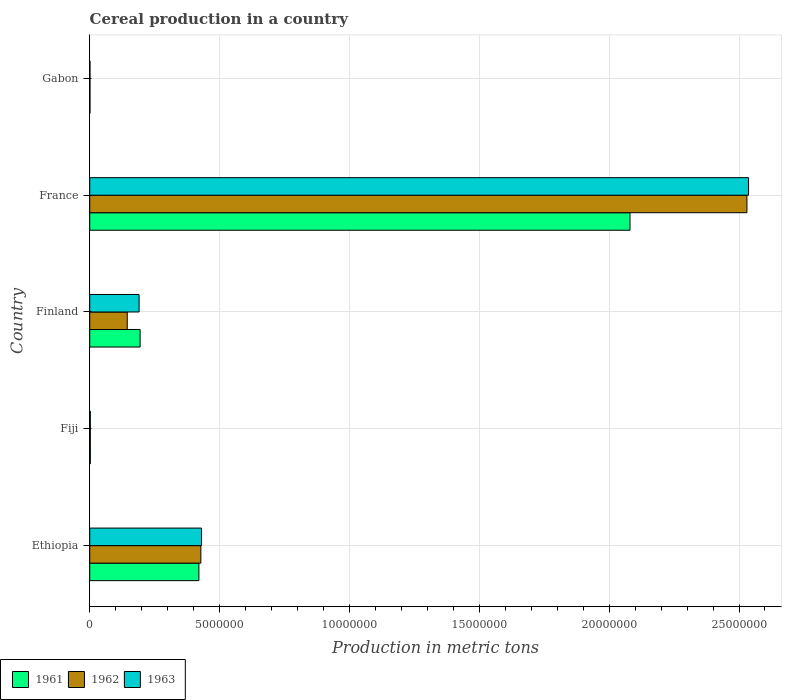How many different coloured bars are there?
Offer a terse response. 3. How many bars are there on the 1st tick from the top?
Ensure brevity in your answer.  3. How many bars are there on the 5th tick from the bottom?
Provide a succinct answer. 3. What is the label of the 4th group of bars from the top?
Offer a very short reply. Fiji. In how many cases, is the number of bars for a given country not equal to the number of legend labels?
Make the answer very short. 0. What is the total cereal production in 1963 in France?
Your answer should be very brief. 2.54e+07. Across all countries, what is the maximum total cereal production in 1963?
Your answer should be very brief. 2.54e+07. Across all countries, what is the minimum total cereal production in 1962?
Provide a short and direct response. 9053. In which country was the total cereal production in 1962 maximum?
Provide a short and direct response. France. In which country was the total cereal production in 1962 minimum?
Provide a succinct answer. Gabon. What is the total total cereal production in 1962 in the graph?
Provide a short and direct response. 3.11e+07. What is the difference between the total cereal production in 1963 in Fiji and that in Gabon?
Offer a very short reply. 1.30e+04. What is the difference between the total cereal production in 1962 in Fiji and the total cereal production in 1961 in Finland?
Your answer should be very brief. -1.92e+06. What is the average total cereal production in 1962 per country?
Offer a very short reply. 6.21e+06. What is the difference between the total cereal production in 1961 and total cereal production in 1963 in Gabon?
Provide a succinct answer. 112. In how many countries, is the total cereal production in 1963 greater than 13000000 metric tons?
Offer a terse response. 1. What is the ratio of the total cereal production in 1963 in Finland to that in Gabon?
Your answer should be very brief. 207.21. Is the total cereal production in 1962 in Ethiopia less than that in France?
Offer a terse response. Yes. Is the difference between the total cereal production in 1961 in Ethiopia and France greater than the difference between the total cereal production in 1963 in Ethiopia and France?
Your answer should be compact. Yes. What is the difference between the highest and the second highest total cereal production in 1961?
Keep it short and to the point. 1.66e+07. What is the difference between the highest and the lowest total cereal production in 1961?
Give a very brief answer. 2.08e+07. In how many countries, is the total cereal production in 1961 greater than the average total cereal production in 1961 taken over all countries?
Provide a succinct answer. 1. What is the difference between two consecutive major ticks on the X-axis?
Your answer should be very brief. 5.00e+06. Does the graph contain any zero values?
Offer a terse response. No. Where does the legend appear in the graph?
Offer a terse response. Bottom left. How many legend labels are there?
Provide a short and direct response. 3. What is the title of the graph?
Make the answer very short. Cereal production in a country. Does "1979" appear as one of the legend labels in the graph?
Your answer should be compact. No. What is the label or title of the X-axis?
Provide a succinct answer. Production in metric tons. What is the Production in metric tons in 1961 in Ethiopia?
Your answer should be very brief. 4.20e+06. What is the Production in metric tons of 1962 in Ethiopia?
Provide a short and direct response. 4.28e+06. What is the Production in metric tons in 1963 in Ethiopia?
Your answer should be compact. 4.30e+06. What is the Production in metric tons of 1961 in Fiji?
Provide a succinct answer. 2.30e+04. What is the Production in metric tons in 1962 in Fiji?
Give a very brief answer. 2.27e+04. What is the Production in metric tons in 1963 in Fiji?
Your response must be concise. 2.22e+04. What is the Production in metric tons in 1961 in Finland?
Your response must be concise. 1.94e+06. What is the Production in metric tons in 1962 in Finland?
Give a very brief answer. 1.44e+06. What is the Production in metric tons in 1963 in Finland?
Ensure brevity in your answer.  1.90e+06. What is the Production in metric tons of 1961 in France?
Ensure brevity in your answer.  2.08e+07. What is the Production in metric tons in 1962 in France?
Provide a succinct answer. 2.53e+07. What is the Production in metric tons of 1963 in France?
Your answer should be very brief. 2.54e+07. What is the Production in metric tons of 1961 in Gabon?
Offer a terse response. 9285. What is the Production in metric tons in 1962 in Gabon?
Ensure brevity in your answer.  9053. What is the Production in metric tons in 1963 in Gabon?
Provide a succinct answer. 9173. Across all countries, what is the maximum Production in metric tons in 1961?
Your answer should be very brief. 2.08e+07. Across all countries, what is the maximum Production in metric tons in 1962?
Ensure brevity in your answer.  2.53e+07. Across all countries, what is the maximum Production in metric tons of 1963?
Make the answer very short. 2.54e+07. Across all countries, what is the minimum Production in metric tons in 1961?
Offer a very short reply. 9285. Across all countries, what is the minimum Production in metric tons in 1962?
Your response must be concise. 9053. Across all countries, what is the minimum Production in metric tons of 1963?
Give a very brief answer. 9173. What is the total Production in metric tons of 1961 in the graph?
Offer a very short reply. 2.70e+07. What is the total Production in metric tons of 1962 in the graph?
Provide a short and direct response. 3.11e+07. What is the total Production in metric tons in 1963 in the graph?
Give a very brief answer. 3.16e+07. What is the difference between the Production in metric tons in 1961 in Ethiopia and that in Fiji?
Offer a terse response. 4.18e+06. What is the difference between the Production in metric tons of 1962 in Ethiopia and that in Fiji?
Provide a succinct answer. 4.26e+06. What is the difference between the Production in metric tons in 1963 in Ethiopia and that in Fiji?
Provide a short and direct response. 4.28e+06. What is the difference between the Production in metric tons in 1961 in Ethiopia and that in Finland?
Your answer should be compact. 2.26e+06. What is the difference between the Production in metric tons in 1962 in Ethiopia and that in Finland?
Your answer should be very brief. 2.83e+06. What is the difference between the Production in metric tons of 1963 in Ethiopia and that in Finland?
Offer a very short reply. 2.40e+06. What is the difference between the Production in metric tons of 1961 in Ethiopia and that in France?
Your answer should be very brief. -1.66e+07. What is the difference between the Production in metric tons of 1962 in Ethiopia and that in France?
Your answer should be very brief. -2.10e+07. What is the difference between the Production in metric tons in 1963 in Ethiopia and that in France?
Your response must be concise. -2.11e+07. What is the difference between the Production in metric tons in 1961 in Ethiopia and that in Gabon?
Ensure brevity in your answer.  4.19e+06. What is the difference between the Production in metric tons in 1962 in Ethiopia and that in Gabon?
Provide a short and direct response. 4.27e+06. What is the difference between the Production in metric tons in 1963 in Ethiopia and that in Gabon?
Offer a terse response. 4.29e+06. What is the difference between the Production in metric tons in 1961 in Fiji and that in Finland?
Keep it short and to the point. -1.92e+06. What is the difference between the Production in metric tons of 1962 in Fiji and that in Finland?
Give a very brief answer. -1.42e+06. What is the difference between the Production in metric tons in 1963 in Fiji and that in Finland?
Your response must be concise. -1.88e+06. What is the difference between the Production in metric tons of 1961 in Fiji and that in France?
Your answer should be very brief. -2.08e+07. What is the difference between the Production in metric tons in 1962 in Fiji and that in France?
Offer a terse response. -2.53e+07. What is the difference between the Production in metric tons of 1963 in Fiji and that in France?
Keep it short and to the point. -2.53e+07. What is the difference between the Production in metric tons in 1961 in Fiji and that in Gabon?
Your response must be concise. 1.37e+04. What is the difference between the Production in metric tons of 1962 in Fiji and that in Gabon?
Your response must be concise. 1.36e+04. What is the difference between the Production in metric tons of 1963 in Fiji and that in Gabon?
Keep it short and to the point. 1.30e+04. What is the difference between the Production in metric tons in 1961 in Finland and that in France?
Your answer should be compact. -1.89e+07. What is the difference between the Production in metric tons in 1962 in Finland and that in France?
Your answer should be very brief. -2.39e+07. What is the difference between the Production in metric tons in 1963 in Finland and that in France?
Your answer should be compact. -2.35e+07. What is the difference between the Production in metric tons in 1961 in Finland and that in Gabon?
Offer a terse response. 1.93e+06. What is the difference between the Production in metric tons in 1962 in Finland and that in Gabon?
Offer a very short reply. 1.44e+06. What is the difference between the Production in metric tons of 1963 in Finland and that in Gabon?
Offer a terse response. 1.89e+06. What is the difference between the Production in metric tons in 1961 in France and that in Gabon?
Make the answer very short. 2.08e+07. What is the difference between the Production in metric tons of 1962 in France and that in Gabon?
Offer a very short reply. 2.53e+07. What is the difference between the Production in metric tons of 1963 in France and that in Gabon?
Give a very brief answer. 2.54e+07. What is the difference between the Production in metric tons of 1961 in Ethiopia and the Production in metric tons of 1962 in Fiji?
Make the answer very short. 4.18e+06. What is the difference between the Production in metric tons in 1961 in Ethiopia and the Production in metric tons in 1963 in Fiji?
Your answer should be compact. 4.18e+06. What is the difference between the Production in metric tons in 1962 in Ethiopia and the Production in metric tons in 1963 in Fiji?
Your answer should be very brief. 4.26e+06. What is the difference between the Production in metric tons in 1961 in Ethiopia and the Production in metric tons in 1962 in Finland?
Offer a very short reply. 2.76e+06. What is the difference between the Production in metric tons of 1961 in Ethiopia and the Production in metric tons of 1963 in Finland?
Give a very brief answer. 2.30e+06. What is the difference between the Production in metric tons in 1962 in Ethiopia and the Production in metric tons in 1963 in Finland?
Make the answer very short. 2.38e+06. What is the difference between the Production in metric tons of 1961 in Ethiopia and the Production in metric tons of 1962 in France?
Provide a succinct answer. -2.11e+07. What is the difference between the Production in metric tons in 1961 in Ethiopia and the Production in metric tons in 1963 in France?
Keep it short and to the point. -2.12e+07. What is the difference between the Production in metric tons in 1962 in Ethiopia and the Production in metric tons in 1963 in France?
Make the answer very short. -2.11e+07. What is the difference between the Production in metric tons in 1961 in Ethiopia and the Production in metric tons in 1962 in Gabon?
Keep it short and to the point. 4.19e+06. What is the difference between the Production in metric tons of 1961 in Ethiopia and the Production in metric tons of 1963 in Gabon?
Keep it short and to the point. 4.19e+06. What is the difference between the Production in metric tons of 1962 in Ethiopia and the Production in metric tons of 1963 in Gabon?
Your answer should be compact. 4.27e+06. What is the difference between the Production in metric tons in 1961 in Fiji and the Production in metric tons in 1962 in Finland?
Offer a terse response. -1.42e+06. What is the difference between the Production in metric tons in 1961 in Fiji and the Production in metric tons in 1963 in Finland?
Your answer should be compact. -1.88e+06. What is the difference between the Production in metric tons of 1962 in Fiji and the Production in metric tons of 1963 in Finland?
Provide a short and direct response. -1.88e+06. What is the difference between the Production in metric tons in 1961 in Fiji and the Production in metric tons in 1962 in France?
Offer a very short reply. -2.53e+07. What is the difference between the Production in metric tons in 1961 in Fiji and the Production in metric tons in 1963 in France?
Keep it short and to the point. -2.53e+07. What is the difference between the Production in metric tons of 1962 in Fiji and the Production in metric tons of 1963 in France?
Provide a succinct answer. -2.53e+07. What is the difference between the Production in metric tons of 1961 in Fiji and the Production in metric tons of 1962 in Gabon?
Offer a terse response. 1.39e+04. What is the difference between the Production in metric tons in 1961 in Fiji and the Production in metric tons in 1963 in Gabon?
Ensure brevity in your answer.  1.38e+04. What is the difference between the Production in metric tons in 1962 in Fiji and the Production in metric tons in 1963 in Gabon?
Offer a terse response. 1.35e+04. What is the difference between the Production in metric tons of 1961 in Finland and the Production in metric tons of 1962 in France?
Provide a short and direct response. -2.34e+07. What is the difference between the Production in metric tons in 1961 in Finland and the Production in metric tons in 1963 in France?
Provide a succinct answer. -2.34e+07. What is the difference between the Production in metric tons in 1962 in Finland and the Production in metric tons in 1963 in France?
Give a very brief answer. -2.39e+07. What is the difference between the Production in metric tons in 1961 in Finland and the Production in metric tons in 1962 in Gabon?
Offer a terse response. 1.93e+06. What is the difference between the Production in metric tons in 1961 in Finland and the Production in metric tons in 1963 in Gabon?
Offer a terse response. 1.93e+06. What is the difference between the Production in metric tons in 1962 in Finland and the Production in metric tons in 1963 in Gabon?
Provide a short and direct response. 1.44e+06. What is the difference between the Production in metric tons of 1961 in France and the Production in metric tons of 1962 in Gabon?
Offer a very short reply. 2.08e+07. What is the difference between the Production in metric tons in 1961 in France and the Production in metric tons in 1963 in Gabon?
Make the answer very short. 2.08e+07. What is the difference between the Production in metric tons of 1962 in France and the Production in metric tons of 1963 in Gabon?
Keep it short and to the point. 2.53e+07. What is the average Production in metric tons in 1961 per country?
Provide a short and direct response. 5.40e+06. What is the average Production in metric tons in 1962 per country?
Provide a succinct answer. 6.21e+06. What is the average Production in metric tons of 1963 per country?
Make the answer very short. 6.32e+06. What is the difference between the Production in metric tons in 1961 and Production in metric tons in 1962 in Ethiopia?
Make the answer very short. -7.60e+04. What is the difference between the Production in metric tons of 1961 and Production in metric tons of 1963 in Ethiopia?
Provide a short and direct response. -1.01e+05. What is the difference between the Production in metric tons in 1962 and Production in metric tons in 1963 in Ethiopia?
Give a very brief answer. -2.50e+04. What is the difference between the Production in metric tons of 1961 and Production in metric tons of 1962 in Fiji?
Your answer should be compact. 305. What is the difference between the Production in metric tons of 1961 and Production in metric tons of 1963 in Fiji?
Your answer should be very brief. 783. What is the difference between the Production in metric tons in 1962 and Production in metric tons in 1963 in Fiji?
Make the answer very short. 478. What is the difference between the Production in metric tons in 1961 and Production in metric tons in 1962 in Finland?
Keep it short and to the point. 4.95e+05. What is the difference between the Production in metric tons of 1961 and Production in metric tons of 1963 in Finland?
Make the answer very short. 3.88e+04. What is the difference between the Production in metric tons of 1962 and Production in metric tons of 1963 in Finland?
Ensure brevity in your answer.  -4.56e+05. What is the difference between the Production in metric tons in 1961 and Production in metric tons in 1962 in France?
Provide a short and direct response. -4.50e+06. What is the difference between the Production in metric tons of 1961 and Production in metric tons of 1963 in France?
Ensure brevity in your answer.  -4.56e+06. What is the difference between the Production in metric tons in 1962 and Production in metric tons in 1963 in France?
Your answer should be compact. -6.22e+04. What is the difference between the Production in metric tons in 1961 and Production in metric tons in 1962 in Gabon?
Your response must be concise. 232. What is the difference between the Production in metric tons of 1961 and Production in metric tons of 1963 in Gabon?
Provide a short and direct response. 112. What is the difference between the Production in metric tons in 1962 and Production in metric tons in 1963 in Gabon?
Offer a very short reply. -120. What is the ratio of the Production in metric tons in 1961 in Ethiopia to that in Fiji?
Keep it short and to the point. 182.74. What is the ratio of the Production in metric tons in 1962 in Ethiopia to that in Fiji?
Keep it short and to the point. 188.54. What is the ratio of the Production in metric tons of 1963 in Ethiopia to that in Fiji?
Your answer should be compact. 193.73. What is the ratio of the Production in metric tons in 1961 in Ethiopia to that in Finland?
Offer a terse response. 2.17. What is the ratio of the Production in metric tons in 1962 in Ethiopia to that in Finland?
Offer a very short reply. 2.96. What is the ratio of the Production in metric tons in 1963 in Ethiopia to that in Finland?
Provide a short and direct response. 2.26. What is the ratio of the Production in metric tons of 1961 in Ethiopia to that in France?
Provide a succinct answer. 0.2. What is the ratio of the Production in metric tons in 1962 in Ethiopia to that in France?
Give a very brief answer. 0.17. What is the ratio of the Production in metric tons of 1963 in Ethiopia to that in France?
Provide a short and direct response. 0.17. What is the ratio of the Production in metric tons of 1961 in Ethiopia to that in Gabon?
Give a very brief answer. 452.67. What is the ratio of the Production in metric tons in 1962 in Ethiopia to that in Gabon?
Your answer should be very brief. 472.66. What is the ratio of the Production in metric tons in 1963 in Ethiopia to that in Gabon?
Offer a terse response. 469.2. What is the ratio of the Production in metric tons in 1961 in Fiji to that in Finland?
Your answer should be very brief. 0.01. What is the ratio of the Production in metric tons in 1962 in Fiji to that in Finland?
Your answer should be very brief. 0.02. What is the ratio of the Production in metric tons in 1963 in Fiji to that in Finland?
Your response must be concise. 0.01. What is the ratio of the Production in metric tons of 1961 in Fiji to that in France?
Offer a terse response. 0. What is the ratio of the Production in metric tons of 1962 in Fiji to that in France?
Ensure brevity in your answer.  0. What is the ratio of the Production in metric tons in 1963 in Fiji to that in France?
Your answer should be compact. 0. What is the ratio of the Production in metric tons of 1961 in Fiji to that in Gabon?
Make the answer very short. 2.48. What is the ratio of the Production in metric tons in 1962 in Fiji to that in Gabon?
Your answer should be compact. 2.51. What is the ratio of the Production in metric tons of 1963 in Fiji to that in Gabon?
Give a very brief answer. 2.42. What is the ratio of the Production in metric tons of 1961 in Finland to that in France?
Ensure brevity in your answer.  0.09. What is the ratio of the Production in metric tons of 1962 in Finland to that in France?
Ensure brevity in your answer.  0.06. What is the ratio of the Production in metric tons in 1963 in Finland to that in France?
Offer a very short reply. 0.07. What is the ratio of the Production in metric tons in 1961 in Finland to that in Gabon?
Your answer should be very brief. 208.89. What is the ratio of the Production in metric tons of 1962 in Finland to that in Gabon?
Provide a short and direct response. 159.54. What is the ratio of the Production in metric tons in 1963 in Finland to that in Gabon?
Your response must be concise. 207.21. What is the ratio of the Production in metric tons of 1961 in France to that in Gabon?
Your answer should be compact. 2240.44. What is the ratio of the Production in metric tons in 1962 in France to that in Gabon?
Provide a succinct answer. 2795.22. What is the ratio of the Production in metric tons in 1963 in France to that in Gabon?
Offer a terse response. 2765.43. What is the difference between the highest and the second highest Production in metric tons in 1961?
Ensure brevity in your answer.  1.66e+07. What is the difference between the highest and the second highest Production in metric tons of 1962?
Give a very brief answer. 2.10e+07. What is the difference between the highest and the second highest Production in metric tons in 1963?
Provide a succinct answer. 2.11e+07. What is the difference between the highest and the lowest Production in metric tons of 1961?
Your answer should be compact. 2.08e+07. What is the difference between the highest and the lowest Production in metric tons in 1962?
Provide a short and direct response. 2.53e+07. What is the difference between the highest and the lowest Production in metric tons of 1963?
Give a very brief answer. 2.54e+07. 